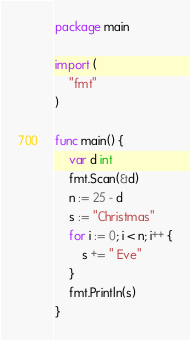<code> <loc_0><loc_0><loc_500><loc_500><_Go_>package main

import (
	"fmt"
)

func main() {
	var d int
	fmt.Scan(&d)
	n := 25 - d
	s := "Christmas"
	for i := 0; i < n; i++ {
		s += " Eve"
	}
	fmt.Println(s)
}
</code> 